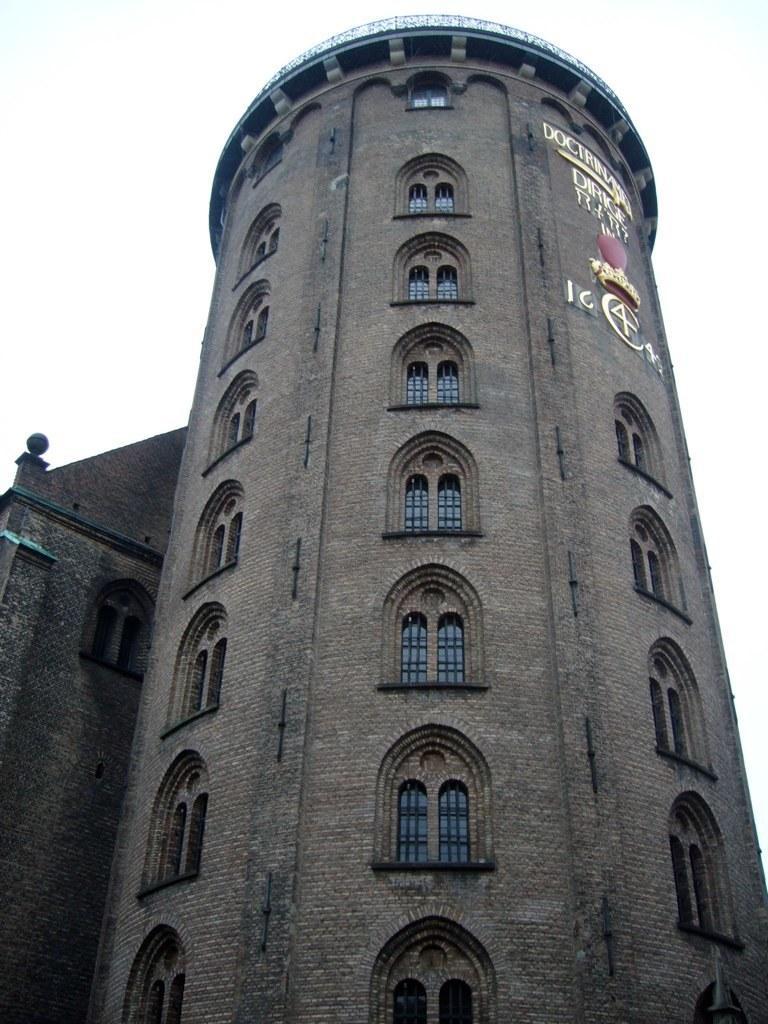Describe this image in one or two sentences. In the center of the image we can see the sky, clouds, one building, windows and a few other objects. On the building, we can see some text. 